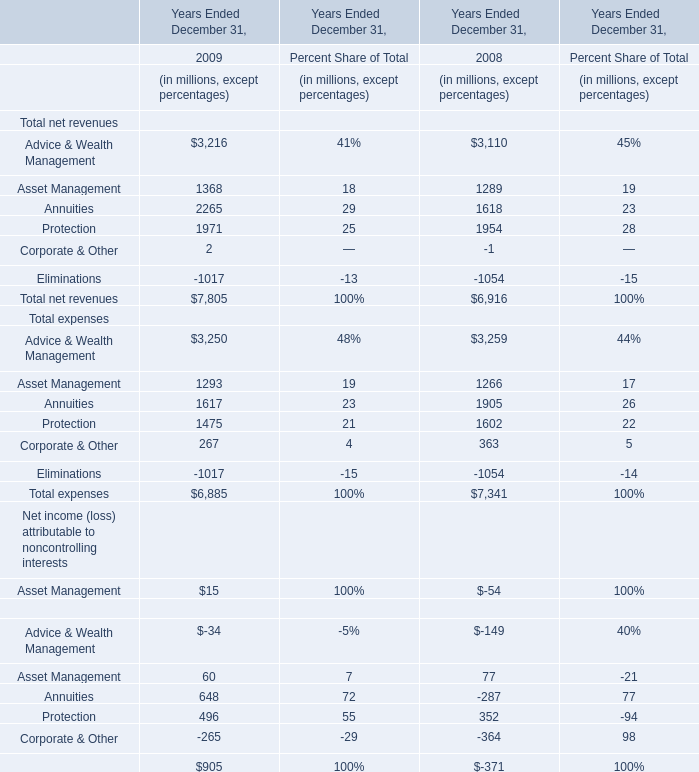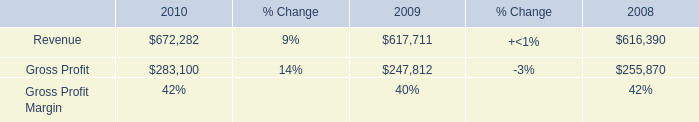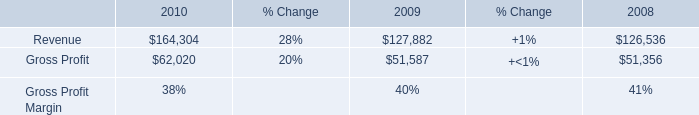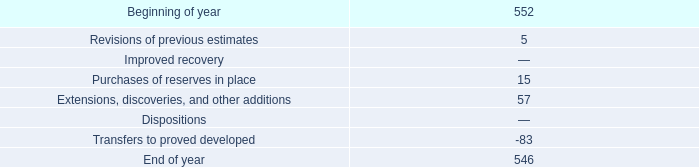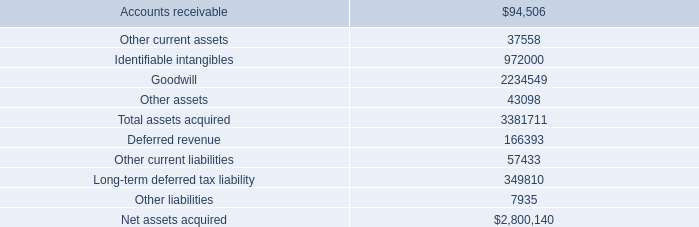What's the average of the Protection in the years where Annuities is positive? (in million) 
Answer: 496. 